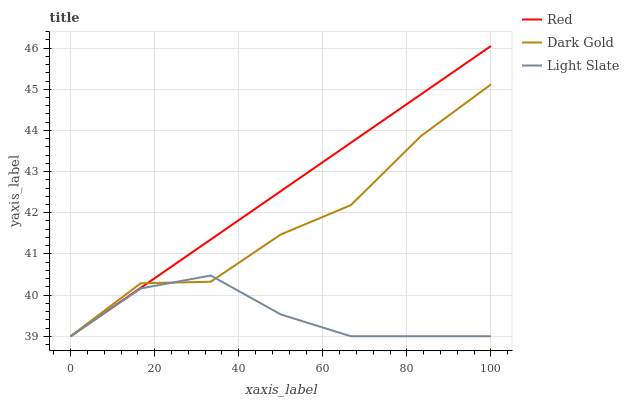Does Light Slate have the minimum area under the curve?
Answer yes or no. Yes. Does Red have the maximum area under the curve?
Answer yes or no. Yes. Does Dark Gold have the minimum area under the curve?
Answer yes or no. No. Does Dark Gold have the maximum area under the curve?
Answer yes or no. No. Is Red the smoothest?
Answer yes or no. Yes. Is Dark Gold the roughest?
Answer yes or no. Yes. Is Dark Gold the smoothest?
Answer yes or no. No. Is Red the roughest?
Answer yes or no. No. Does Light Slate have the lowest value?
Answer yes or no. Yes. Does Red have the highest value?
Answer yes or no. Yes. Does Dark Gold have the highest value?
Answer yes or no. No. Does Dark Gold intersect Red?
Answer yes or no. Yes. Is Dark Gold less than Red?
Answer yes or no. No. Is Dark Gold greater than Red?
Answer yes or no. No. 